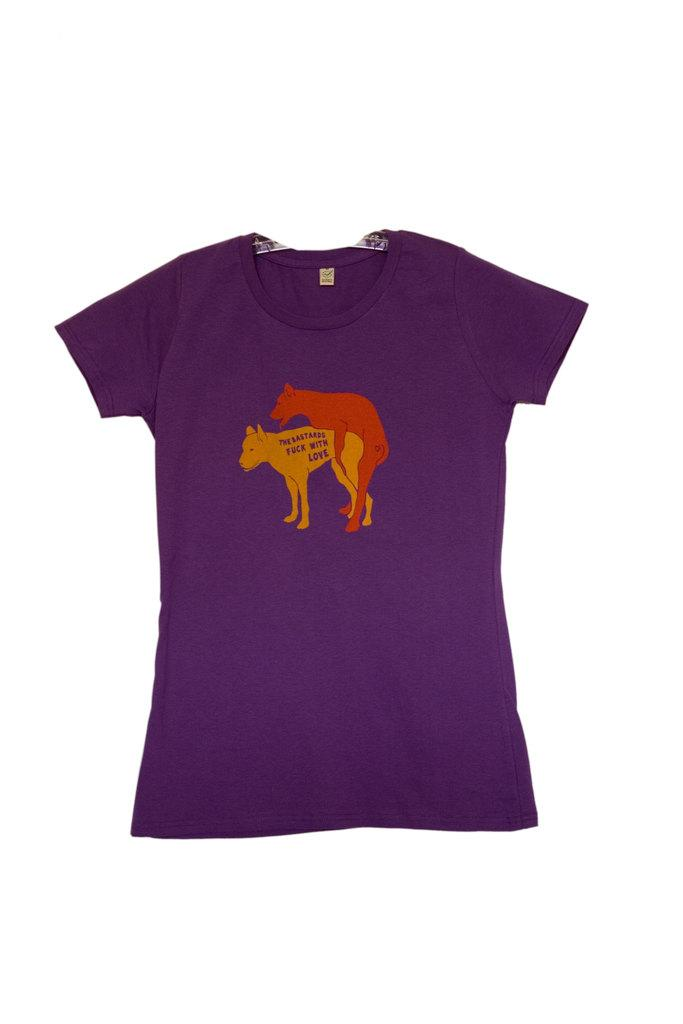What color is the t-shirt in the image? The t-shirt is blue in color. What can be seen on the t-shirt? There are pictures of animals on the t-shirt. What type of soap is used to clean the animals on the t-shirt? There is no soap present in the image, as it only features a blue t-shirt with pictures of animals. 